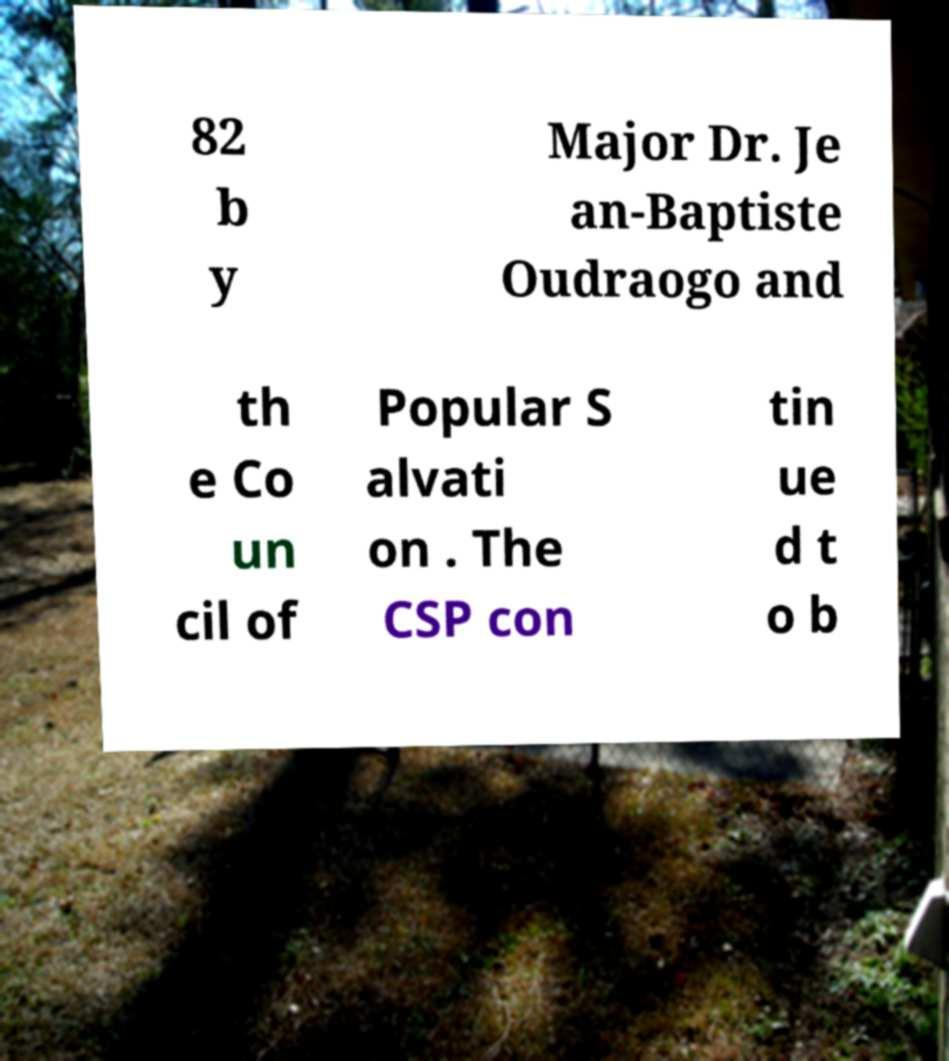I need the written content from this picture converted into text. Can you do that? 82 b y Major Dr. Je an-Baptiste Oudraogo and th e Co un cil of Popular S alvati on . The CSP con tin ue d t o b 